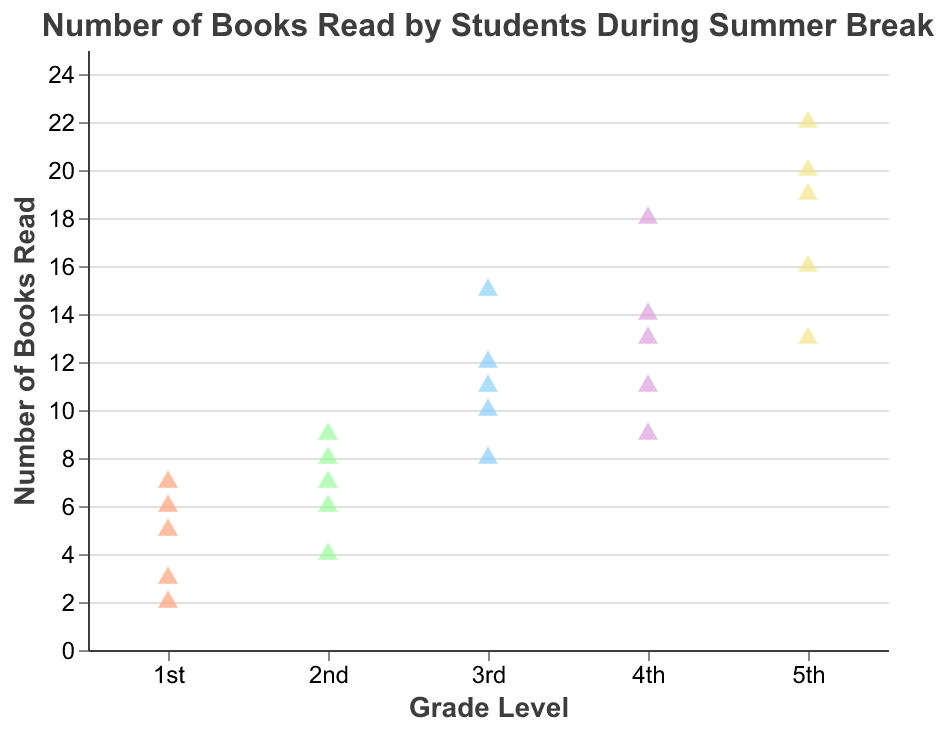What is the title of the figure? The title can be found at the top of the figure. It summarizes what the visualization is about. Here, the title states, "Number of Books Read by Students During Summer Break."
Answer: Number of Books Read by Students During Summer Break Which grade level read the most books in any single instance? By examining the highest points on the y-axis for each grade level, we see that a 5th grader read 22 books, which is the most in any single instance.
Answer: 5th grade What is the range of books read by 1st graders? Look at the number of points for 1st grade and identify the minimum and maximum values. For 1st graders, books read range from 2 to 7.
Answer: 2 to 7 How many books did the average 3rd grader read? To find the average, sum the number of books read by 3rd graders (12 + 10 + 15 + 8 + 11), which is 56. Divide this by the number of data points (5). 56/5 = 11.2
Answer: 11.2 Which grade level has the highest average number of books read? Calculate the average for each grade level and compare them.
1st: (5+3+7+2+6)/5 = 4.6
2nd: (8+4+9+6+7)/5 = 6.8
3rd: (12+10+15+8+11)/5 = 11.2
4th: (14+11+18+9+13)/5 = 13
5th: (20+16+22+13+19)/5 = 18
The 5th grade has the highest average with 18 books.
Answer: 5th grade How many more books did the most diligent 5th grader read compared to the most diligent 1st grader? The most diligent 5th grader read 22 books, and the most diligent 1st grader read 7 books. The difference is 22 - 7.
Answer: 15 Which grade level has the most points (students)? Count the number of data points for each grade level. All grade levels have 5 points each, so they are equal in number of students.
Answer: All equal How does the number of books read by the average 4th grader compare to that by the average 2nd grader? Calculate the averages as before.
4th: (14+11+18+9+13)/5 = 13
2nd: (8+4+9+6+7)/5 = 6.8
The average 4th grader reads more books than the average 2nd grader (13 > 6.8).
Answer: 4th graders read more How varied are the 1st grader's reading habits compared to the 5th graders'? Compare the range between the highest and lowest values for both grades.
1st grade: 7 - 2 = 5
5th grade: 22 - 13 = 9
1st graders exhibit a range of 5, while 5th graders exhibit a range of 9, indicating more variation in reading habits for 5th graders.
Answer: 5th graders have a more varied range 